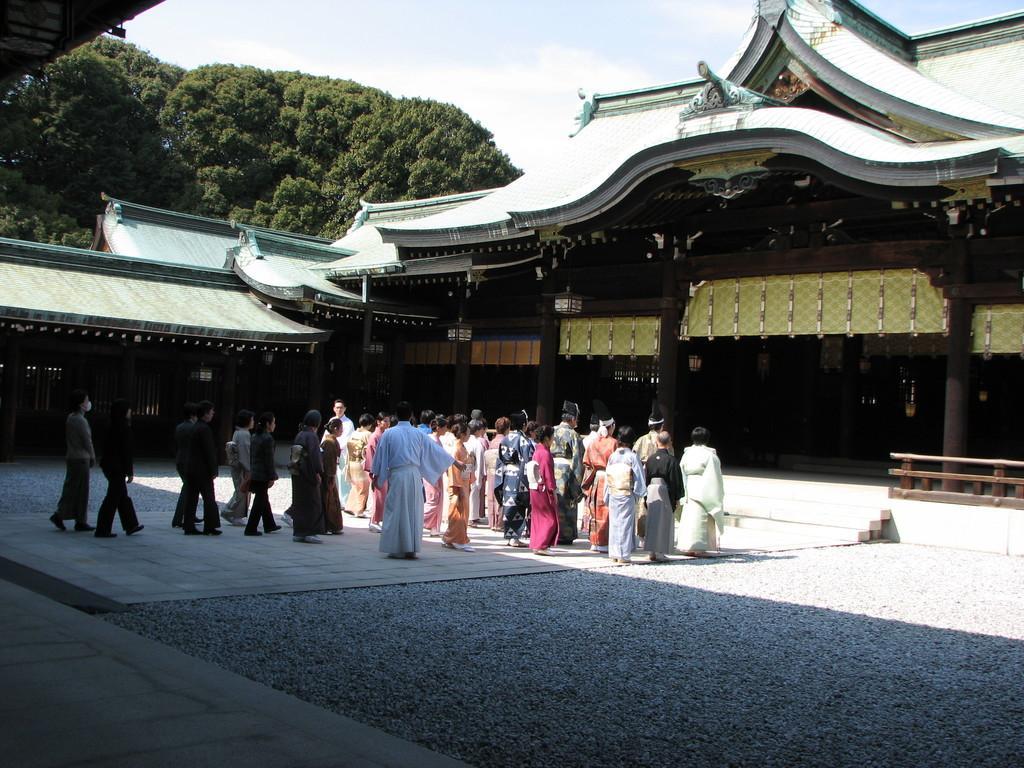In one or two sentences, can you explain what this image depicts? In this image I can see a building. There are group of people, pillars, lights, trees, stairs and in the background there is sky. 